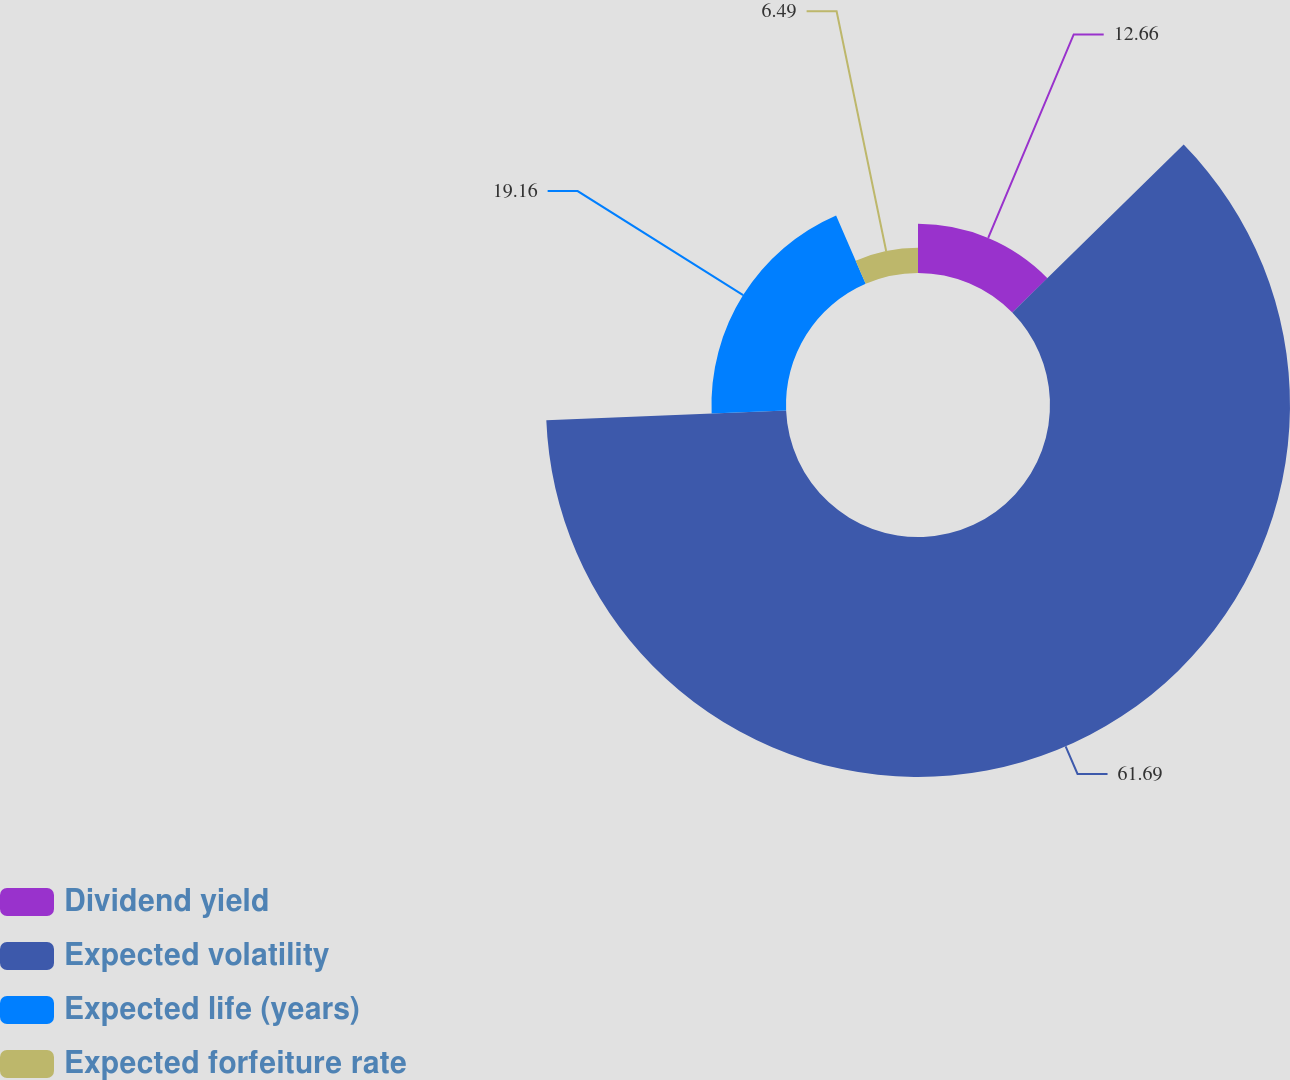<chart> <loc_0><loc_0><loc_500><loc_500><pie_chart><fcel>Dividend yield<fcel>Expected volatility<fcel>Expected life (years)<fcel>Expected forfeiture rate<nl><fcel>12.66%<fcel>61.69%<fcel>19.16%<fcel>6.49%<nl></chart> 